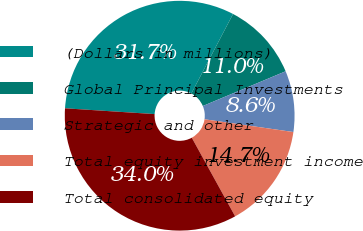Convert chart. <chart><loc_0><loc_0><loc_500><loc_500><pie_chart><fcel>(Dollars in millions)<fcel>Global Principal Investments<fcel>Strategic and other<fcel>Total equity investment income<fcel>Total consolidated equity<nl><fcel>31.66%<fcel>10.99%<fcel>8.59%<fcel>14.71%<fcel>34.05%<nl></chart> 